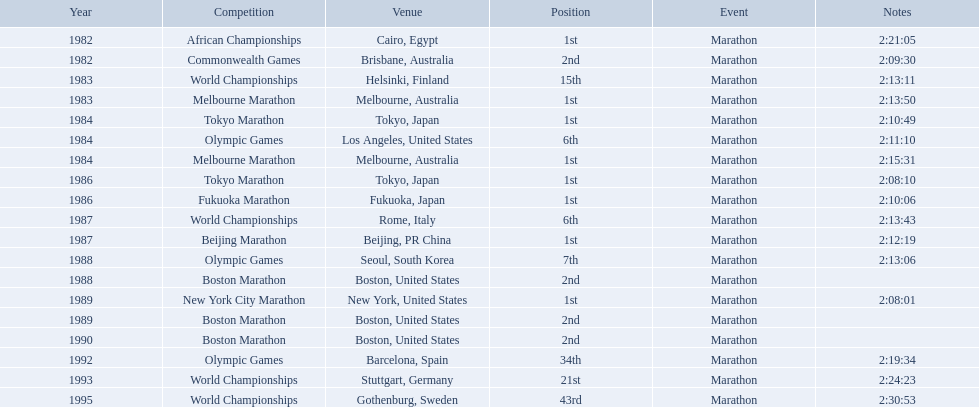What are all the competitions? African Championships, Commonwealth Games, World Championships, Melbourne Marathon, Tokyo Marathon, Olympic Games, Melbourne Marathon, Tokyo Marathon, Fukuoka Marathon, World Championships, Beijing Marathon, Olympic Games, Boston Marathon, New York City Marathon, Boston Marathon, Boston Marathon, Olympic Games, World Championships, World Championships. Where were they located? Cairo, Egypt, Brisbane, Australia, Helsinki, Finland, Melbourne, Australia, Tokyo, Japan, Los Angeles, United States, Melbourne, Australia, Tokyo, Japan, Fukuoka, Japan, Rome, Italy, Beijing, PR China, Seoul, South Korea, Boston, United States, New York, United States, Boston, United States, Boston, United States, Barcelona, Spain, Stuttgart, Germany, Gothenburg, Sweden. And which competition was in china? Beijing Marathon. What are the numerous challenges? African Championships, Commonwealth Games, World Championships, Melbourne Marathon, Tokyo Marathon, Olympic Games, Melbourne Marathon, Tokyo Marathon, Fukuoka Marathon, World Championships, Beijing Marathon, Olympic Games, Boston Marathon, New York City Marathon, Boston Marathon, Boston Marathon, Olympic Games, World Championships, World Championships. Where were they positioned? Cairo, Egypt, Brisbane, Australia, Helsinki, Finland, Melbourne, Australia, Tokyo, Japan, Los Angeles, United States, Melbourne, Australia, Tokyo, Japan, Fukuoka, Japan, Rome, Italy, Beijing, PR China, Seoul, South Korea, Boston, United States, New York, United States, Boston, United States, Boston, United States, Barcelona, Spain, Stuttgart, Germany, Gothenburg, Sweden. And which challenge was held in china? Beijing Marathon. What are the contests? African Championships, Cairo, Egypt, Commonwealth Games, Brisbane, Australia, World Championships, Helsinki, Finland, Melbourne Marathon, Melbourne, Australia, Tokyo Marathon, Tokyo, Japan, Olympic Games, Los Angeles, United States, Melbourne Marathon, Melbourne, Australia, Tokyo Marathon, Tokyo, Japan, Fukuoka Marathon, Fukuoka, Japan, World Championships, Rome, Italy, Beijing Marathon, Beijing, PR China, Olympic Games, Seoul, South Korea, Boston Marathon, Boston, United States, New York City Marathon, New York, United States, Boston Marathon, Boston, United States, Boston Marathon, Boston, United States, Olympic Games, Barcelona, Spain, World Championships, Stuttgart, Germany, World Championships, Gothenburg, Sweden. Which ones took place in china? Beijing Marathon, Beijing, PR China. Which one is it? Beijing Marathon. What are all of the juma ikangaa races? African Championships, Commonwealth Games, World Championships, Melbourne Marathon, Tokyo Marathon, Olympic Games, Melbourne Marathon, Tokyo Marathon, Fukuoka Marathon, World Championships, Beijing Marathon, Olympic Games, Boston Marathon, New York City Marathon, Boston Marathon, Boston Marathon, Olympic Games, World Championships, World Championships. Which of these races did not unfold in the united states? African Championships, Commonwealth Games, World Championships, Melbourne Marathon, Tokyo Marathon, Melbourne Marathon, Tokyo Marathon, Fukuoka Marathon, World Championships, Beijing Marathon, Olympic Games, Olympic Games, World Championships, World Championships. Out of these, which of them took place in asia? Tokyo Marathon, Tokyo Marathon, Fukuoka Marathon, Beijing Marathon, Olympic Games. Which of the remaining races happened in china? Beijing Marathon. What are the rivalries? African Championships, Cairo, Egypt, Commonwealth Games, Brisbane, Australia, World Championships, Helsinki, Finland, Melbourne Marathon, Melbourne, Australia, Tokyo Marathon, Tokyo, Japan, Olympic Games, Los Angeles, United States, Melbourne Marathon, Melbourne, Australia, Tokyo Marathon, Tokyo, Japan, Fukuoka Marathon, Fukuoka, Japan, World Championships, Rome, Italy, Beijing Marathon, Beijing, PR China, Olympic Games, Seoul, South Korea, Boston Marathon, Boston, United States, New York City Marathon, New York, United States, Boston Marathon, Boston, United States, Boston Marathon, Boston, United States, Olympic Games, Barcelona, Spain, World Championships, Stuttgart, Germany, World Championships, Gothenburg, Sweden. Which ones transpired in china? Beijing Marathon, Beijing, PR China. Which one is it? Beijing Marathon. What are the various contests? African Championships, Commonwealth Games, World Championships, Melbourne Marathon, Tokyo Marathon, Olympic Games, Melbourne Marathon, Tokyo Marathon, Fukuoka Marathon, World Championships, Beijing Marathon, Olympic Games, Boston Marathon, New York City Marathon, Boston Marathon, Boston Marathon, Olympic Games, World Championships, World Championships. Where were they situated? Cairo, Egypt, Brisbane, Australia, Helsinki, Finland, Melbourne, Australia, Tokyo, Japan, Los Angeles, United States, Melbourne, Australia, Tokyo, Japan, Fukuoka, Japan, Rome, Italy, Beijing, PR China, Seoul, South Korea, Boston, United States, New York, United States, Boston, United States, Boston, United States, Barcelona, Spain, Stuttgart, Germany, Gothenburg, Sweden. And which contest took place in china? Beijing Marathon. What are the competitive events? African Championships, Cairo, Egypt, Commonwealth Games, Brisbane, Australia, World Championships, Helsinki, Finland, Melbourne Marathon, Melbourne, Australia, Tokyo Marathon, Tokyo, Japan, Olympic Games, Los Angeles, United States, Melbourne Marathon, Melbourne, Australia, Tokyo Marathon, Tokyo, Japan, Fukuoka Marathon, Fukuoka, Japan, World Championships, Rome, Italy, Beijing Marathon, Beijing, PR China, Olympic Games, Seoul, South Korea, Boston Marathon, Boston, United States, New York City Marathon, New York, United States, Boston Marathon, Boston, United States, Boston Marathon, Boston, United States, Olympic Games, Barcelona, Spain, World Championships, Stuttgart, Germany, World Championships, Gothenburg, Sweden. Which of these took place in china? Beijing Marathon, Beijing, PR China. Which specific event is being referred to? Beijing Marathon. What kind of contests are there? African Championships, Cairo, Egypt, Commonwealth Games, Brisbane, Australia, World Championships, Helsinki, Finland, Melbourne Marathon, Melbourne, Australia, Tokyo Marathon, Tokyo, Japan, Olympic Games, Los Angeles, United States, Melbourne Marathon, Melbourne, Australia, Tokyo Marathon, Tokyo, Japan, Fukuoka Marathon, Fukuoka, Japan, World Championships, Rome, Italy, Beijing Marathon, Beijing, PR China, Olympic Games, Seoul, South Korea, Boston Marathon, Boston, United States, New York City Marathon, New York, United States, Boston Marathon, Boston, United States, Boston Marathon, Boston, United States, Olympic Games, Barcelona, Spain, World Championships, Stuttgart, Germany, World Championships, Gothenburg, Sweden. Which ones happened in china? Beijing Marathon, Beijing, PR China. Which particular one is being discussed? Beijing Marathon. 